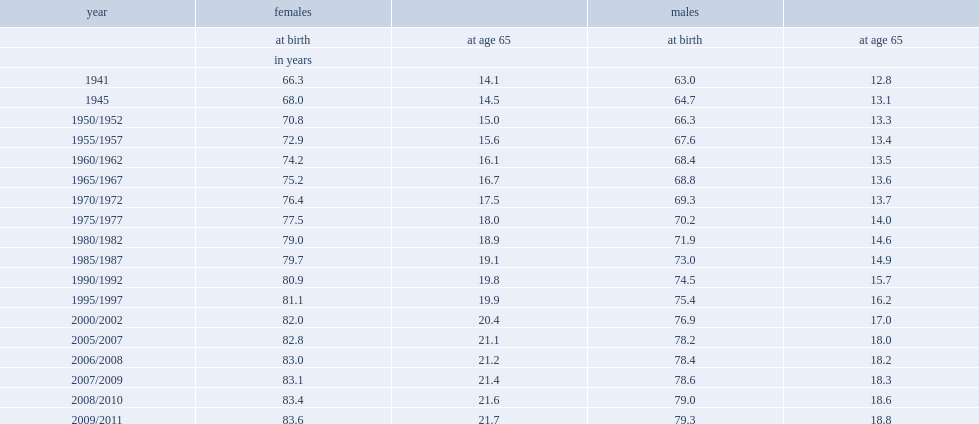In 1941, at age 65, how many years could women expect to live ? 14.1. In 1941, at age 65, how many years could men expect to live ? 12.8. In 1941, at age 65, women and men could expect to live an additional 14.1 and 12.8 years, respectively, what was a difference of men and women? 1.3. 